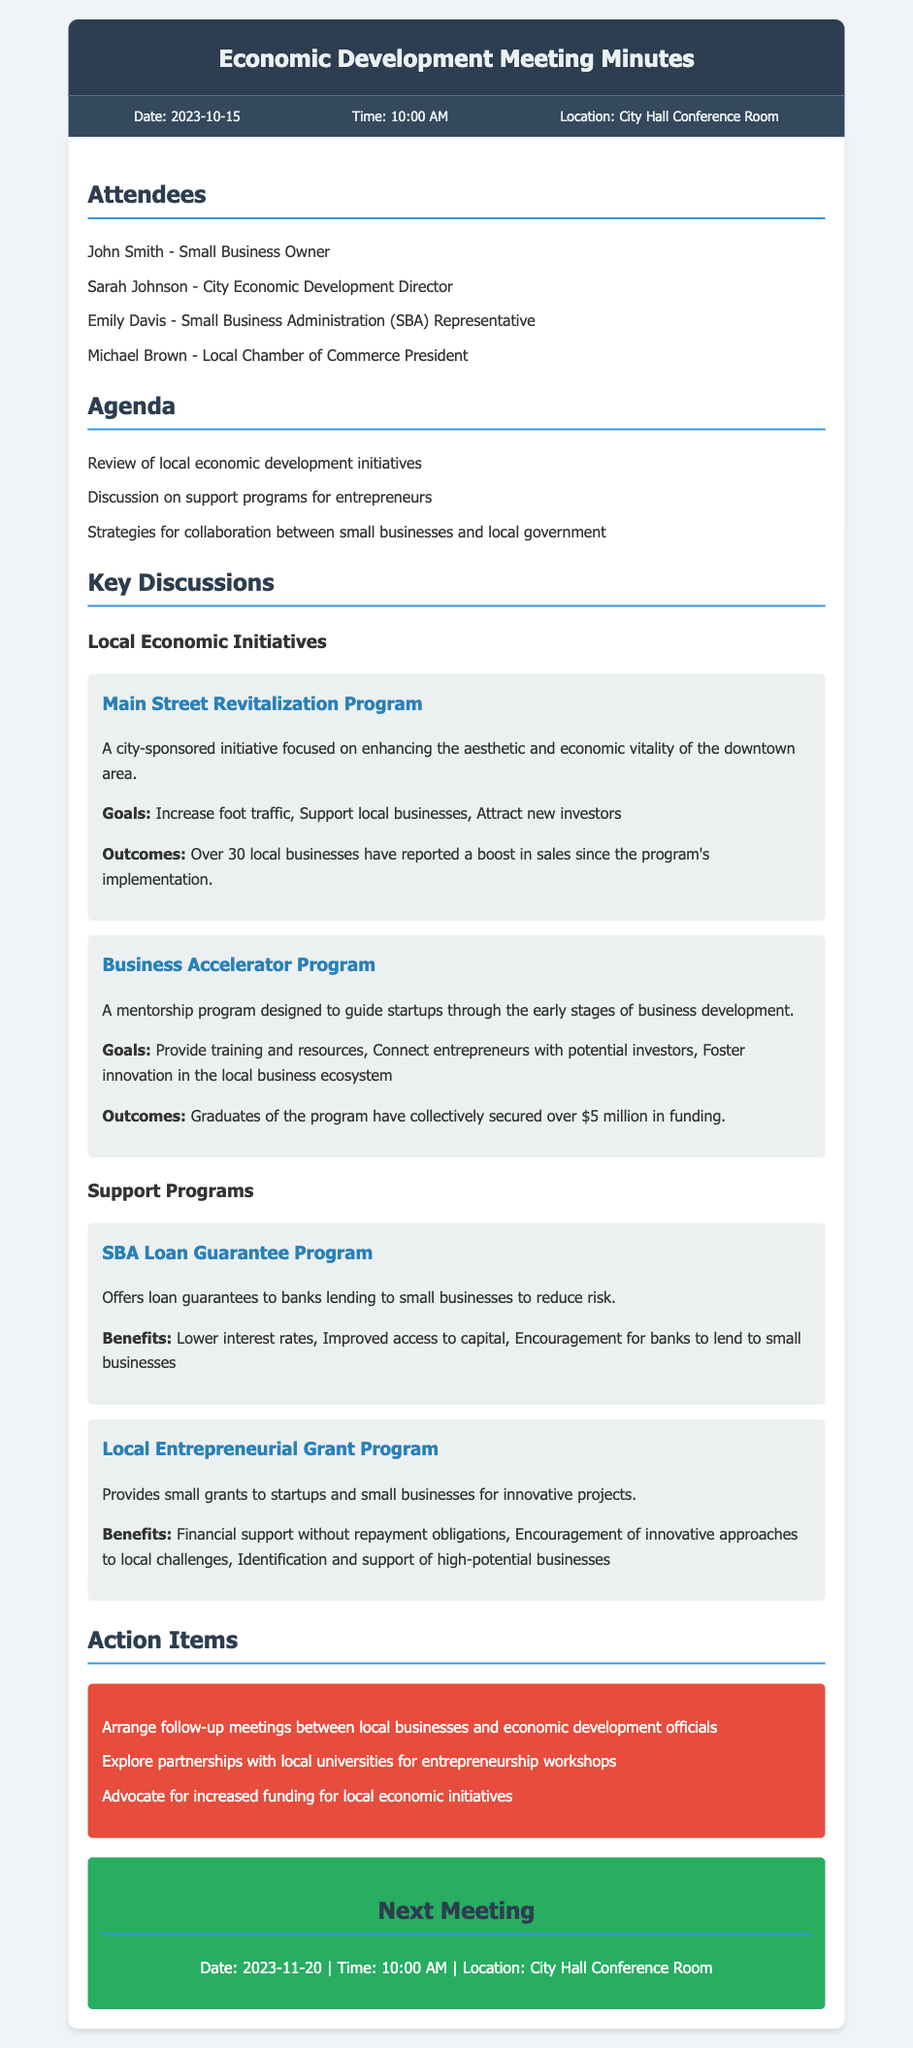What is the date of the meeting? The date of the meeting is specified in the meeting information section.
Answer: 2023-10-15 Who is the City Economic Development Director? The document lists attendees, including their titles.
Answer: Sarah Johnson What is the goal of the Main Street Revitalization Program? The goals of the initiative are outlined in the key discussions section.
Answer: Increase foot traffic How much funding have graduates of the Business Accelerator Program secured? This information is provided under the outcomes of the program in the document.
Answer: Over $5 million What type of support does the SBA Loan Guarantee Program offer? The document describes the program's function under support programs.
Answer: Loan guarantees What is a benefit of the Local Entrepreneurial Grant Program? The benefits of this program are highlighted in the document.
Answer: Financial support without repayment obligations What action item involves local businesses and officials? The action items section describes various tasks agreed upon during the meeting.
Answer: Arrange follow-up meetings When is the next meeting scheduled? The next meeting's date is included in the document.
Answer: 2023-11-20 